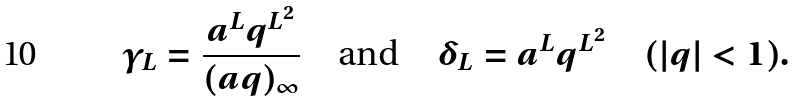Convert formula to latex. <formula><loc_0><loc_0><loc_500><loc_500>\gamma _ { L } = \frac { a ^ { L } q ^ { L ^ { 2 } } } { ( a q ) _ { \infty } } \quad \text {and} \quad \delta _ { L } = a ^ { L } q ^ { L ^ { 2 } } \quad ( | q | < 1 ) .</formula> 